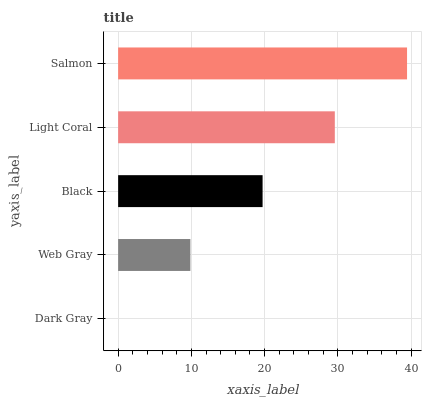Is Dark Gray the minimum?
Answer yes or no. Yes. Is Salmon the maximum?
Answer yes or no. Yes. Is Web Gray the minimum?
Answer yes or no. No. Is Web Gray the maximum?
Answer yes or no. No. Is Web Gray greater than Dark Gray?
Answer yes or no. Yes. Is Dark Gray less than Web Gray?
Answer yes or no. Yes. Is Dark Gray greater than Web Gray?
Answer yes or no. No. Is Web Gray less than Dark Gray?
Answer yes or no. No. Is Black the high median?
Answer yes or no. Yes. Is Black the low median?
Answer yes or no. Yes. Is Light Coral the high median?
Answer yes or no. No. Is Web Gray the low median?
Answer yes or no. No. 